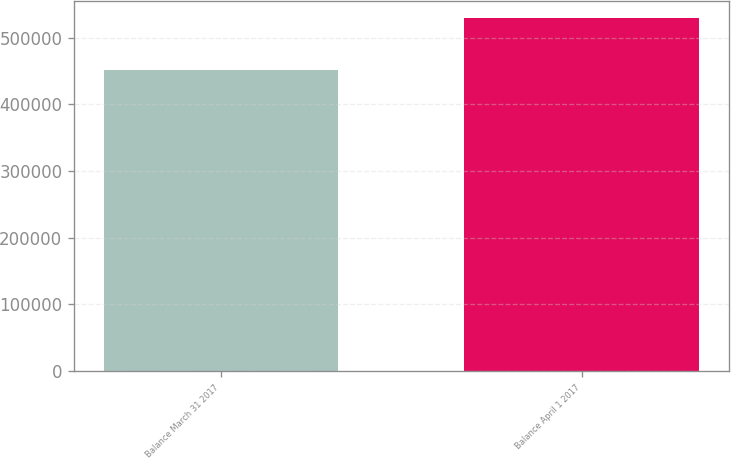Convert chart. <chart><loc_0><loc_0><loc_500><loc_500><bar_chart><fcel>Balance March 31 2017<fcel>Balance April 1 2017<nl><fcel>452071<fcel>529152<nl></chart> 